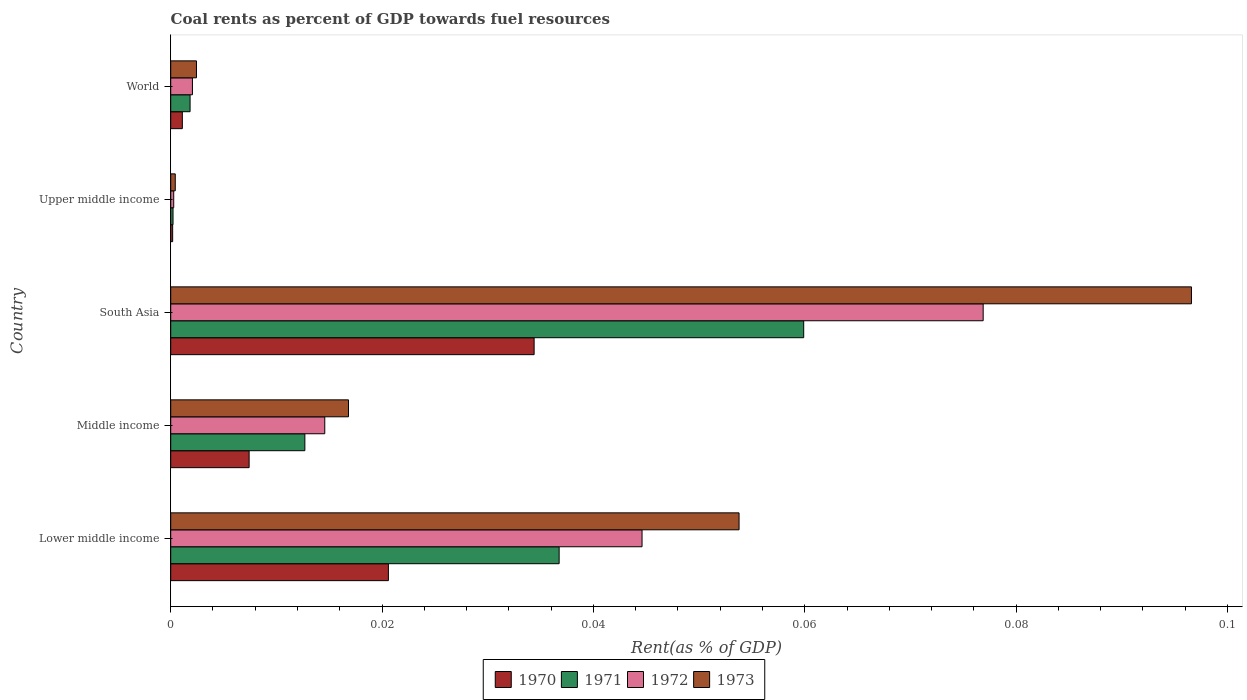How many groups of bars are there?
Your answer should be compact. 5. Are the number of bars per tick equal to the number of legend labels?
Ensure brevity in your answer.  Yes. Are the number of bars on each tick of the Y-axis equal?
Offer a terse response. Yes. How many bars are there on the 5th tick from the top?
Provide a succinct answer. 4. In how many cases, is the number of bars for a given country not equal to the number of legend labels?
Your response must be concise. 0. What is the coal rent in 1972 in Upper middle income?
Offer a very short reply. 0. Across all countries, what is the maximum coal rent in 1970?
Ensure brevity in your answer.  0.03. Across all countries, what is the minimum coal rent in 1970?
Your answer should be compact. 0. In which country was the coal rent in 1973 minimum?
Your answer should be very brief. Upper middle income. What is the total coal rent in 1970 in the graph?
Ensure brevity in your answer.  0.06. What is the difference between the coal rent in 1972 in Upper middle income and that in World?
Provide a succinct answer. -0. What is the difference between the coal rent in 1972 in South Asia and the coal rent in 1970 in Upper middle income?
Ensure brevity in your answer.  0.08. What is the average coal rent in 1970 per country?
Keep it short and to the point. 0.01. What is the difference between the coal rent in 1971 and coal rent in 1970 in Upper middle income?
Your answer should be very brief. 3.4968209641675e-5. What is the ratio of the coal rent in 1970 in Lower middle income to that in Middle income?
Offer a very short reply. 2.78. Is the difference between the coal rent in 1971 in Middle income and South Asia greater than the difference between the coal rent in 1970 in Middle income and South Asia?
Your answer should be very brief. No. What is the difference between the highest and the second highest coal rent in 1971?
Give a very brief answer. 0.02. What is the difference between the highest and the lowest coal rent in 1973?
Make the answer very short. 0.1. In how many countries, is the coal rent in 1971 greater than the average coal rent in 1971 taken over all countries?
Offer a very short reply. 2. Is it the case that in every country, the sum of the coal rent in 1971 and coal rent in 1973 is greater than the sum of coal rent in 1972 and coal rent in 1970?
Ensure brevity in your answer.  No. What does the 3rd bar from the top in Middle income represents?
Offer a terse response. 1971. What does the 2nd bar from the bottom in South Asia represents?
Make the answer very short. 1971. Is it the case that in every country, the sum of the coal rent in 1971 and coal rent in 1973 is greater than the coal rent in 1972?
Keep it short and to the point. Yes. How many bars are there?
Offer a very short reply. 20. Are all the bars in the graph horizontal?
Offer a terse response. Yes. Does the graph contain any zero values?
Make the answer very short. No. How many legend labels are there?
Offer a terse response. 4. How are the legend labels stacked?
Your response must be concise. Horizontal. What is the title of the graph?
Offer a very short reply. Coal rents as percent of GDP towards fuel resources. What is the label or title of the X-axis?
Offer a very short reply. Rent(as % of GDP). What is the Rent(as % of GDP) of 1970 in Lower middle income?
Your answer should be compact. 0.02. What is the Rent(as % of GDP) in 1971 in Lower middle income?
Keep it short and to the point. 0.04. What is the Rent(as % of GDP) in 1972 in Lower middle income?
Provide a succinct answer. 0.04. What is the Rent(as % of GDP) of 1973 in Lower middle income?
Your answer should be compact. 0.05. What is the Rent(as % of GDP) of 1970 in Middle income?
Your answer should be very brief. 0.01. What is the Rent(as % of GDP) of 1971 in Middle income?
Your answer should be compact. 0.01. What is the Rent(as % of GDP) of 1972 in Middle income?
Your answer should be very brief. 0.01. What is the Rent(as % of GDP) of 1973 in Middle income?
Your answer should be very brief. 0.02. What is the Rent(as % of GDP) of 1970 in South Asia?
Offer a terse response. 0.03. What is the Rent(as % of GDP) of 1971 in South Asia?
Provide a succinct answer. 0.06. What is the Rent(as % of GDP) in 1972 in South Asia?
Provide a short and direct response. 0.08. What is the Rent(as % of GDP) of 1973 in South Asia?
Your answer should be very brief. 0.1. What is the Rent(as % of GDP) in 1970 in Upper middle income?
Ensure brevity in your answer.  0. What is the Rent(as % of GDP) in 1971 in Upper middle income?
Offer a terse response. 0. What is the Rent(as % of GDP) in 1972 in Upper middle income?
Keep it short and to the point. 0. What is the Rent(as % of GDP) of 1973 in Upper middle income?
Ensure brevity in your answer.  0. What is the Rent(as % of GDP) of 1970 in World?
Offer a very short reply. 0. What is the Rent(as % of GDP) in 1971 in World?
Provide a short and direct response. 0. What is the Rent(as % of GDP) of 1972 in World?
Ensure brevity in your answer.  0. What is the Rent(as % of GDP) in 1973 in World?
Your response must be concise. 0. Across all countries, what is the maximum Rent(as % of GDP) in 1970?
Provide a short and direct response. 0.03. Across all countries, what is the maximum Rent(as % of GDP) in 1971?
Provide a short and direct response. 0.06. Across all countries, what is the maximum Rent(as % of GDP) of 1972?
Ensure brevity in your answer.  0.08. Across all countries, what is the maximum Rent(as % of GDP) in 1973?
Ensure brevity in your answer.  0.1. Across all countries, what is the minimum Rent(as % of GDP) of 1970?
Your answer should be very brief. 0. Across all countries, what is the minimum Rent(as % of GDP) in 1971?
Offer a very short reply. 0. Across all countries, what is the minimum Rent(as % of GDP) in 1972?
Provide a succinct answer. 0. Across all countries, what is the minimum Rent(as % of GDP) of 1973?
Give a very brief answer. 0. What is the total Rent(as % of GDP) of 1970 in the graph?
Make the answer very short. 0.06. What is the total Rent(as % of GDP) of 1971 in the graph?
Offer a very short reply. 0.11. What is the total Rent(as % of GDP) in 1972 in the graph?
Provide a short and direct response. 0.14. What is the total Rent(as % of GDP) of 1973 in the graph?
Offer a very short reply. 0.17. What is the difference between the Rent(as % of GDP) in 1970 in Lower middle income and that in Middle income?
Give a very brief answer. 0.01. What is the difference between the Rent(as % of GDP) in 1971 in Lower middle income and that in Middle income?
Your response must be concise. 0.02. What is the difference between the Rent(as % of GDP) of 1973 in Lower middle income and that in Middle income?
Offer a terse response. 0.04. What is the difference between the Rent(as % of GDP) in 1970 in Lower middle income and that in South Asia?
Your answer should be very brief. -0.01. What is the difference between the Rent(as % of GDP) of 1971 in Lower middle income and that in South Asia?
Provide a short and direct response. -0.02. What is the difference between the Rent(as % of GDP) in 1972 in Lower middle income and that in South Asia?
Your answer should be compact. -0.03. What is the difference between the Rent(as % of GDP) in 1973 in Lower middle income and that in South Asia?
Your answer should be very brief. -0.04. What is the difference between the Rent(as % of GDP) of 1970 in Lower middle income and that in Upper middle income?
Make the answer very short. 0.02. What is the difference between the Rent(as % of GDP) in 1971 in Lower middle income and that in Upper middle income?
Provide a short and direct response. 0.04. What is the difference between the Rent(as % of GDP) in 1972 in Lower middle income and that in Upper middle income?
Keep it short and to the point. 0.04. What is the difference between the Rent(as % of GDP) in 1973 in Lower middle income and that in Upper middle income?
Keep it short and to the point. 0.05. What is the difference between the Rent(as % of GDP) in 1970 in Lower middle income and that in World?
Ensure brevity in your answer.  0.02. What is the difference between the Rent(as % of GDP) of 1971 in Lower middle income and that in World?
Ensure brevity in your answer.  0.03. What is the difference between the Rent(as % of GDP) of 1972 in Lower middle income and that in World?
Ensure brevity in your answer.  0.04. What is the difference between the Rent(as % of GDP) of 1973 in Lower middle income and that in World?
Ensure brevity in your answer.  0.05. What is the difference between the Rent(as % of GDP) of 1970 in Middle income and that in South Asia?
Ensure brevity in your answer.  -0.03. What is the difference between the Rent(as % of GDP) of 1971 in Middle income and that in South Asia?
Your answer should be very brief. -0.05. What is the difference between the Rent(as % of GDP) of 1972 in Middle income and that in South Asia?
Provide a short and direct response. -0.06. What is the difference between the Rent(as % of GDP) of 1973 in Middle income and that in South Asia?
Offer a terse response. -0.08. What is the difference between the Rent(as % of GDP) of 1970 in Middle income and that in Upper middle income?
Offer a very short reply. 0.01. What is the difference between the Rent(as % of GDP) in 1971 in Middle income and that in Upper middle income?
Ensure brevity in your answer.  0.01. What is the difference between the Rent(as % of GDP) of 1972 in Middle income and that in Upper middle income?
Provide a short and direct response. 0.01. What is the difference between the Rent(as % of GDP) of 1973 in Middle income and that in Upper middle income?
Your answer should be very brief. 0.02. What is the difference between the Rent(as % of GDP) of 1970 in Middle income and that in World?
Provide a short and direct response. 0.01. What is the difference between the Rent(as % of GDP) of 1971 in Middle income and that in World?
Provide a succinct answer. 0.01. What is the difference between the Rent(as % of GDP) of 1972 in Middle income and that in World?
Ensure brevity in your answer.  0.01. What is the difference between the Rent(as % of GDP) in 1973 in Middle income and that in World?
Provide a short and direct response. 0.01. What is the difference between the Rent(as % of GDP) in 1970 in South Asia and that in Upper middle income?
Provide a succinct answer. 0.03. What is the difference between the Rent(as % of GDP) of 1971 in South Asia and that in Upper middle income?
Your response must be concise. 0.06. What is the difference between the Rent(as % of GDP) of 1972 in South Asia and that in Upper middle income?
Offer a terse response. 0.08. What is the difference between the Rent(as % of GDP) of 1973 in South Asia and that in Upper middle income?
Offer a very short reply. 0.1. What is the difference between the Rent(as % of GDP) in 1970 in South Asia and that in World?
Provide a succinct answer. 0.03. What is the difference between the Rent(as % of GDP) of 1971 in South Asia and that in World?
Provide a short and direct response. 0.06. What is the difference between the Rent(as % of GDP) of 1972 in South Asia and that in World?
Keep it short and to the point. 0.07. What is the difference between the Rent(as % of GDP) in 1973 in South Asia and that in World?
Your response must be concise. 0.09. What is the difference between the Rent(as % of GDP) of 1970 in Upper middle income and that in World?
Make the answer very short. -0. What is the difference between the Rent(as % of GDP) in 1971 in Upper middle income and that in World?
Provide a succinct answer. -0. What is the difference between the Rent(as % of GDP) of 1972 in Upper middle income and that in World?
Provide a succinct answer. -0. What is the difference between the Rent(as % of GDP) in 1973 in Upper middle income and that in World?
Provide a short and direct response. -0. What is the difference between the Rent(as % of GDP) of 1970 in Lower middle income and the Rent(as % of GDP) of 1971 in Middle income?
Your answer should be compact. 0.01. What is the difference between the Rent(as % of GDP) of 1970 in Lower middle income and the Rent(as % of GDP) of 1972 in Middle income?
Offer a very short reply. 0.01. What is the difference between the Rent(as % of GDP) in 1970 in Lower middle income and the Rent(as % of GDP) in 1973 in Middle income?
Your response must be concise. 0. What is the difference between the Rent(as % of GDP) in 1971 in Lower middle income and the Rent(as % of GDP) in 1972 in Middle income?
Keep it short and to the point. 0.02. What is the difference between the Rent(as % of GDP) in 1971 in Lower middle income and the Rent(as % of GDP) in 1973 in Middle income?
Provide a succinct answer. 0.02. What is the difference between the Rent(as % of GDP) in 1972 in Lower middle income and the Rent(as % of GDP) in 1973 in Middle income?
Your response must be concise. 0.03. What is the difference between the Rent(as % of GDP) of 1970 in Lower middle income and the Rent(as % of GDP) of 1971 in South Asia?
Provide a succinct answer. -0.04. What is the difference between the Rent(as % of GDP) of 1970 in Lower middle income and the Rent(as % of GDP) of 1972 in South Asia?
Keep it short and to the point. -0.06. What is the difference between the Rent(as % of GDP) in 1970 in Lower middle income and the Rent(as % of GDP) in 1973 in South Asia?
Offer a very short reply. -0.08. What is the difference between the Rent(as % of GDP) in 1971 in Lower middle income and the Rent(as % of GDP) in 1972 in South Asia?
Make the answer very short. -0.04. What is the difference between the Rent(as % of GDP) in 1971 in Lower middle income and the Rent(as % of GDP) in 1973 in South Asia?
Offer a terse response. -0.06. What is the difference between the Rent(as % of GDP) of 1972 in Lower middle income and the Rent(as % of GDP) of 1973 in South Asia?
Your response must be concise. -0.05. What is the difference between the Rent(as % of GDP) of 1970 in Lower middle income and the Rent(as % of GDP) of 1971 in Upper middle income?
Your response must be concise. 0.02. What is the difference between the Rent(as % of GDP) of 1970 in Lower middle income and the Rent(as % of GDP) of 1972 in Upper middle income?
Your answer should be compact. 0.02. What is the difference between the Rent(as % of GDP) of 1970 in Lower middle income and the Rent(as % of GDP) of 1973 in Upper middle income?
Your answer should be compact. 0.02. What is the difference between the Rent(as % of GDP) of 1971 in Lower middle income and the Rent(as % of GDP) of 1972 in Upper middle income?
Provide a short and direct response. 0.04. What is the difference between the Rent(as % of GDP) in 1971 in Lower middle income and the Rent(as % of GDP) in 1973 in Upper middle income?
Your answer should be very brief. 0.04. What is the difference between the Rent(as % of GDP) in 1972 in Lower middle income and the Rent(as % of GDP) in 1973 in Upper middle income?
Your answer should be very brief. 0.04. What is the difference between the Rent(as % of GDP) of 1970 in Lower middle income and the Rent(as % of GDP) of 1971 in World?
Provide a short and direct response. 0.02. What is the difference between the Rent(as % of GDP) of 1970 in Lower middle income and the Rent(as % of GDP) of 1972 in World?
Your answer should be compact. 0.02. What is the difference between the Rent(as % of GDP) of 1970 in Lower middle income and the Rent(as % of GDP) of 1973 in World?
Offer a terse response. 0.02. What is the difference between the Rent(as % of GDP) in 1971 in Lower middle income and the Rent(as % of GDP) in 1972 in World?
Your response must be concise. 0.03. What is the difference between the Rent(as % of GDP) in 1971 in Lower middle income and the Rent(as % of GDP) in 1973 in World?
Give a very brief answer. 0.03. What is the difference between the Rent(as % of GDP) in 1972 in Lower middle income and the Rent(as % of GDP) in 1973 in World?
Provide a succinct answer. 0.04. What is the difference between the Rent(as % of GDP) of 1970 in Middle income and the Rent(as % of GDP) of 1971 in South Asia?
Keep it short and to the point. -0.05. What is the difference between the Rent(as % of GDP) in 1970 in Middle income and the Rent(as % of GDP) in 1972 in South Asia?
Your answer should be compact. -0.07. What is the difference between the Rent(as % of GDP) in 1970 in Middle income and the Rent(as % of GDP) in 1973 in South Asia?
Keep it short and to the point. -0.09. What is the difference between the Rent(as % of GDP) of 1971 in Middle income and the Rent(as % of GDP) of 1972 in South Asia?
Your response must be concise. -0.06. What is the difference between the Rent(as % of GDP) in 1971 in Middle income and the Rent(as % of GDP) in 1973 in South Asia?
Your response must be concise. -0.08. What is the difference between the Rent(as % of GDP) of 1972 in Middle income and the Rent(as % of GDP) of 1973 in South Asia?
Keep it short and to the point. -0.08. What is the difference between the Rent(as % of GDP) of 1970 in Middle income and the Rent(as % of GDP) of 1971 in Upper middle income?
Offer a terse response. 0.01. What is the difference between the Rent(as % of GDP) in 1970 in Middle income and the Rent(as % of GDP) in 1972 in Upper middle income?
Keep it short and to the point. 0.01. What is the difference between the Rent(as % of GDP) in 1970 in Middle income and the Rent(as % of GDP) in 1973 in Upper middle income?
Ensure brevity in your answer.  0.01. What is the difference between the Rent(as % of GDP) of 1971 in Middle income and the Rent(as % of GDP) of 1972 in Upper middle income?
Make the answer very short. 0.01. What is the difference between the Rent(as % of GDP) in 1971 in Middle income and the Rent(as % of GDP) in 1973 in Upper middle income?
Ensure brevity in your answer.  0.01. What is the difference between the Rent(as % of GDP) in 1972 in Middle income and the Rent(as % of GDP) in 1973 in Upper middle income?
Provide a short and direct response. 0.01. What is the difference between the Rent(as % of GDP) in 1970 in Middle income and the Rent(as % of GDP) in 1971 in World?
Provide a succinct answer. 0.01. What is the difference between the Rent(as % of GDP) of 1970 in Middle income and the Rent(as % of GDP) of 1972 in World?
Offer a very short reply. 0.01. What is the difference between the Rent(as % of GDP) in 1970 in Middle income and the Rent(as % of GDP) in 1973 in World?
Provide a short and direct response. 0.01. What is the difference between the Rent(as % of GDP) of 1971 in Middle income and the Rent(as % of GDP) of 1972 in World?
Make the answer very short. 0.01. What is the difference between the Rent(as % of GDP) of 1971 in Middle income and the Rent(as % of GDP) of 1973 in World?
Keep it short and to the point. 0.01. What is the difference between the Rent(as % of GDP) in 1972 in Middle income and the Rent(as % of GDP) in 1973 in World?
Ensure brevity in your answer.  0.01. What is the difference between the Rent(as % of GDP) in 1970 in South Asia and the Rent(as % of GDP) in 1971 in Upper middle income?
Provide a succinct answer. 0.03. What is the difference between the Rent(as % of GDP) in 1970 in South Asia and the Rent(as % of GDP) in 1972 in Upper middle income?
Provide a succinct answer. 0.03. What is the difference between the Rent(as % of GDP) in 1970 in South Asia and the Rent(as % of GDP) in 1973 in Upper middle income?
Keep it short and to the point. 0.03. What is the difference between the Rent(as % of GDP) in 1971 in South Asia and the Rent(as % of GDP) in 1972 in Upper middle income?
Provide a succinct answer. 0.06. What is the difference between the Rent(as % of GDP) in 1971 in South Asia and the Rent(as % of GDP) in 1973 in Upper middle income?
Make the answer very short. 0.06. What is the difference between the Rent(as % of GDP) in 1972 in South Asia and the Rent(as % of GDP) in 1973 in Upper middle income?
Keep it short and to the point. 0.08. What is the difference between the Rent(as % of GDP) of 1970 in South Asia and the Rent(as % of GDP) of 1971 in World?
Provide a short and direct response. 0.03. What is the difference between the Rent(as % of GDP) in 1970 in South Asia and the Rent(as % of GDP) in 1972 in World?
Provide a short and direct response. 0.03. What is the difference between the Rent(as % of GDP) of 1970 in South Asia and the Rent(as % of GDP) of 1973 in World?
Offer a terse response. 0.03. What is the difference between the Rent(as % of GDP) of 1971 in South Asia and the Rent(as % of GDP) of 1972 in World?
Keep it short and to the point. 0.06. What is the difference between the Rent(as % of GDP) of 1971 in South Asia and the Rent(as % of GDP) of 1973 in World?
Provide a short and direct response. 0.06. What is the difference between the Rent(as % of GDP) of 1972 in South Asia and the Rent(as % of GDP) of 1973 in World?
Your answer should be very brief. 0.07. What is the difference between the Rent(as % of GDP) of 1970 in Upper middle income and the Rent(as % of GDP) of 1971 in World?
Provide a succinct answer. -0. What is the difference between the Rent(as % of GDP) of 1970 in Upper middle income and the Rent(as % of GDP) of 1972 in World?
Offer a very short reply. -0. What is the difference between the Rent(as % of GDP) in 1970 in Upper middle income and the Rent(as % of GDP) in 1973 in World?
Keep it short and to the point. -0. What is the difference between the Rent(as % of GDP) of 1971 in Upper middle income and the Rent(as % of GDP) of 1972 in World?
Offer a terse response. -0. What is the difference between the Rent(as % of GDP) of 1971 in Upper middle income and the Rent(as % of GDP) of 1973 in World?
Offer a very short reply. -0. What is the difference between the Rent(as % of GDP) of 1972 in Upper middle income and the Rent(as % of GDP) of 1973 in World?
Keep it short and to the point. -0. What is the average Rent(as % of GDP) of 1970 per country?
Provide a short and direct response. 0.01. What is the average Rent(as % of GDP) in 1971 per country?
Your answer should be very brief. 0.02. What is the average Rent(as % of GDP) of 1972 per country?
Keep it short and to the point. 0.03. What is the average Rent(as % of GDP) of 1973 per country?
Provide a short and direct response. 0.03. What is the difference between the Rent(as % of GDP) of 1970 and Rent(as % of GDP) of 1971 in Lower middle income?
Provide a short and direct response. -0.02. What is the difference between the Rent(as % of GDP) in 1970 and Rent(as % of GDP) in 1972 in Lower middle income?
Offer a very short reply. -0.02. What is the difference between the Rent(as % of GDP) of 1970 and Rent(as % of GDP) of 1973 in Lower middle income?
Your answer should be very brief. -0.03. What is the difference between the Rent(as % of GDP) in 1971 and Rent(as % of GDP) in 1972 in Lower middle income?
Your answer should be very brief. -0.01. What is the difference between the Rent(as % of GDP) in 1971 and Rent(as % of GDP) in 1973 in Lower middle income?
Ensure brevity in your answer.  -0.02. What is the difference between the Rent(as % of GDP) in 1972 and Rent(as % of GDP) in 1973 in Lower middle income?
Keep it short and to the point. -0.01. What is the difference between the Rent(as % of GDP) in 1970 and Rent(as % of GDP) in 1971 in Middle income?
Keep it short and to the point. -0.01. What is the difference between the Rent(as % of GDP) in 1970 and Rent(as % of GDP) in 1972 in Middle income?
Offer a very short reply. -0.01. What is the difference between the Rent(as % of GDP) of 1970 and Rent(as % of GDP) of 1973 in Middle income?
Your answer should be compact. -0.01. What is the difference between the Rent(as % of GDP) in 1971 and Rent(as % of GDP) in 1972 in Middle income?
Your answer should be compact. -0. What is the difference between the Rent(as % of GDP) in 1971 and Rent(as % of GDP) in 1973 in Middle income?
Provide a short and direct response. -0. What is the difference between the Rent(as % of GDP) in 1972 and Rent(as % of GDP) in 1973 in Middle income?
Your answer should be compact. -0. What is the difference between the Rent(as % of GDP) in 1970 and Rent(as % of GDP) in 1971 in South Asia?
Make the answer very short. -0.03. What is the difference between the Rent(as % of GDP) of 1970 and Rent(as % of GDP) of 1972 in South Asia?
Offer a very short reply. -0.04. What is the difference between the Rent(as % of GDP) of 1970 and Rent(as % of GDP) of 1973 in South Asia?
Make the answer very short. -0.06. What is the difference between the Rent(as % of GDP) of 1971 and Rent(as % of GDP) of 1972 in South Asia?
Your response must be concise. -0.02. What is the difference between the Rent(as % of GDP) of 1971 and Rent(as % of GDP) of 1973 in South Asia?
Your response must be concise. -0.04. What is the difference between the Rent(as % of GDP) of 1972 and Rent(as % of GDP) of 1973 in South Asia?
Provide a short and direct response. -0.02. What is the difference between the Rent(as % of GDP) of 1970 and Rent(as % of GDP) of 1972 in Upper middle income?
Your answer should be compact. -0. What is the difference between the Rent(as % of GDP) in 1970 and Rent(as % of GDP) in 1973 in Upper middle income?
Give a very brief answer. -0. What is the difference between the Rent(as % of GDP) of 1971 and Rent(as % of GDP) of 1972 in Upper middle income?
Provide a succinct answer. -0. What is the difference between the Rent(as % of GDP) in 1971 and Rent(as % of GDP) in 1973 in Upper middle income?
Provide a short and direct response. -0. What is the difference between the Rent(as % of GDP) of 1972 and Rent(as % of GDP) of 1973 in Upper middle income?
Provide a short and direct response. -0. What is the difference between the Rent(as % of GDP) of 1970 and Rent(as % of GDP) of 1971 in World?
Ensure brevity in your answer.  -0. What is the difference between the Rent(as % of GDP) of 1970 and Rent(as % of GDP) of 1972 in World?
Your response must be concise. -0. What is the difference between the Rent(as % of GDP) in 1970 and Rent(as % of GDP) in 1973 in World?
Keep it short and to the point. -0. What is the difference between the Rent(as % of GDP) of 1971 and Rent(as % of GDP) of 1972 in World?
Your answer should be compact. -0. What is the difference between the Rent(as % of GDP) in 1971 and Rent(as % of GDP) in 1973 in World?
Provide a succinct answer. -0. What is the difference between the Rent(as % of GDP) of 1972 and Rent(as % of GDP) of 1973 in World?
Keep it short and to the point. -0. What is the ratio of the Rent(as % of GDP) in 1970 in Lower middle income to that in Middle income?
Give a very brief answer. 2.78. What is the ratio of the Rent(as % of GDP) in 1971 in Lower middle income to that in Middle income?
Offer a terse response. 2.9. What is the ratio of the Rent(as % of GDP) in 1972 in Lower middle income to that in Middle income?
Provide a succinct answer. 3.06. What is the ratio of the Rent(as % of GDP) of 1973 in Lower middle income to that in Middle income?
Make the answer very short. 3.2. What is the ratio of the Rent(as % of GDP) in 1970 in Lower middle income to that in South Asia?
Your answer should be compact. 0.6. What is the ratio of the Rent(as % of GDP) in 1971 in Lower middle income to that in South Asia?
Make the answer very short. 0.61. What is the ratio of the Rent(as % of GDP) in 1972 in Lower middle income to that in South Asia?
Provide a short and direct response. 0.58. What is the ratio of the Rent(as % of GDP) of 1973 in Lower middle income to that in South Asia?
Offer a very short reply. 0.56. What is the ratio of the Rent(as % of GDP) of 1970 in Lower middle income to that in Upper middle income?
Give a very brief answer. 112.03. What is the ratio of the Rent(as % of GDP) of 1971 in Lower middle income to that in Upper middle income?
Make the answer very short. 167.98. What is the ratio of the Rent(as % of GDP) in 1972 in Lower middle income to that in Upper middle income?
Provide a succinct answer. 156.82. What is the ratio of the Rent(as % of GDP) of 1973 in Lower middle income to that in Upper middle income?
Your answer should be very brief. 124.82. What is the ratio of the Rent(as % of GDP) of 1970 in Lower middle income to that in World?
Provide a succinct answer. 18.71. What is the ratio of the Rent(as % of GDP) in 1971 in Lower middle income to that in World?
Your response must be concise. 20.06. What is the ratio of the Rent(as % of GDP) in 1972 in Lower middle income to that in World?
Provide a succinct answer. 21.7. What is the ratio of the Rent(as % of GDP) in 1973 in Lower middle income to that in World?
Your answer should be compact. 22.07. What is the ratio of the Rent(as % of GDP) in 1970 in Middle income to that in South Asia?
Keep it short and to the point. 0.22. What is the ratio of the Rent(as % of GDP) in 1971 in Middle income to that in South Asia?
Your answer should be very brief. 0.21. What is the ratio of the Rent(as % of GDP) in 1972 in Middle income to that in South Asia?
Your answer should be very brief. 0.19. What is the ratio of the Rent(as % of GDP) of 1973 in Middle income to that in South Asia?
Offer a very short reply. 0.17. What is the ratio of the Rent(as % of GDP) of 1970 in Middle income to that in Upper middle income?
Provide a succinct answer. 40.36. What is the ratio of the Rent(as % of GDP) of 1971 in Middle income to that in Upper middle income?
Keep it short and to the point. 58.01. What is the ratio of the Rent(as % of GDP) of 1972 in Middle income to that in Upper middle income?
Ensure brevity in your answer.  51.25. What is the ratio of the Rent(as % of GDP) of 1973 in Middle income to that in Upper middle income?
Your answer should be very brief. 39.04. What is the ratio of the Rent(as % of GDP) of 1970 in Middle income to that in World?
Offer a very short reply. 6.74. What is the ratio of the Rent(as % of GDP) in 1971 in Middle income to that in World?
Your response must be concise. 6.93. What is the ratio of the Rent(as % of GDP) of 1972 in Middle income to that in World?
Offer a very short reply. 7.09. What is the ratio of the Rent(as % of GDP) of 1973 in Middle income to that in World?
Give a very brief answer. 6.91. What is the ratio of the Rent(as % of GDP) of 1970 in South Asia to that in Upper middle income?
Give a very brief answer. 187.05. What is the ratio of the Rent(as % of GDP) in 1971 in South Asia to that in Upper middle income?
Your answer should be compact. 273.74. What is the ratio of the Rent(as % of GDP) in 1972 in South Asia to that in Upper middle income?
Your response must be concise. 270.32. What is the ratio of the Rent(as % of GDP) in 1973 in South Asia to that in Upper middle income?
Keep it short and to the point. 224.18. What is the ratio of the Rent(as % of GDP) of 1970 in South Asia to that in World?
Provide a succinct answer. 31.24. What is the ratio of the Rent(as % of GDP) in 1971 in South Asia to that in World?
Provide a short and direct response. 32.69. What is the ratio of the Rent(as % of GDP) of 1972 in South Asia to that in World?
Your answer should be compact. 37.41. What is the ratio of the Rent(as % of GDP) of 1973 in South Asia to that in World?
Provide a short and direct response. 39.65. What is the ratio of the Rent(as % of GDP) in 1970 in Upper middle income to that in World?
Offer a very short reply. 0.17. What is the ratio of the Rent(as % of GDP) in 1971 in Upper middle income to that in World?
Keep it short and to the point. 0.12. What is the ratio of the Rent(as % of GDP) in 1972 in Upper middle income to that in World?
Keep it short and to the point. 0.14. What is the ratio of the Rent(as % of GDP) of 1973 in Upper middle income to that in World?
Keep it short and to the point. 0.18. What is the difference between the highest and the second highest Rent(as % of GDP) of 1970?
Ensure brevity in your answer.  0.01. What is the difference between the highest and the second highest Rent(as % of GDP) of 1971?
Provide a short and direct response. 0.02. What is the difference between the highest and the second highest Rent(as % of GDP) in 1972?
Keep it short and to the point. 0.03. What is the difference between the highest and the second highest Rent(as % of GDP) of 1973?
Give a very brief answer. 0.04. What is the difference between the highest and the lowest Rent(as % of GDP) in 1970?
Your answer should be compact. 0.03. What is the difference between the highest and the lowest Rent(as % of GDP) in 1971?
Offer a very short reply. 0.06. What is the difference between the highest and the lowest Rent(as % of GDP) of 1972?
Make the answer very short. 0.08. What is the difference between the highest and the lowest Rent(as % of GDP) in 1973?
Your response must be concise. 0.1. 